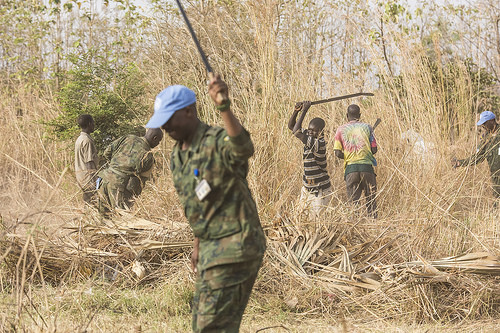<image>
Can you confirm if the grass is behind the hat? Yes. From this viewpoint, the grass is positioned behind the hat, with the hat partially or fully occluding the grass. 